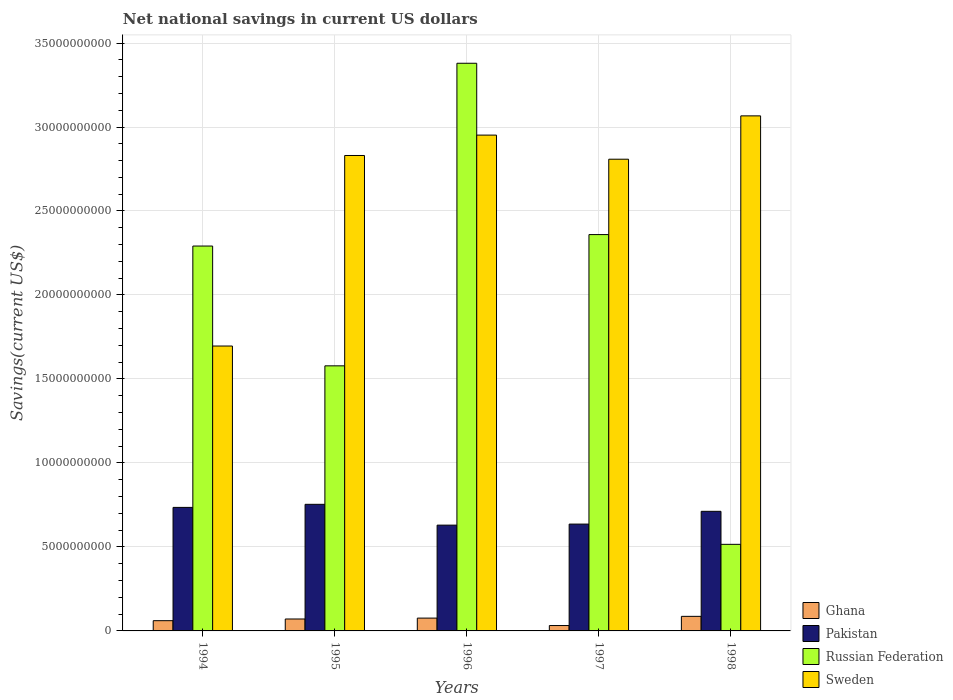How many different coloured bars are there?
Ensure brevity in your answer.  4. How many groups of bars are there?
Your answer should be compact. 5. Are the number of bars on each tick of the X-axis equal?
Keep it short and to the point. Yes. How many bars are there on the 2nd tick from the left?
Make the answer very short. 4. How many bars are there on the 3rd tick from the right?
Keep it short and to the point. 4. What is the net national savings in Russian Federation in 1998?
Ensure brevity in your answer.  5.16e+09. Across all years, what is the maximum net national savings in Sweden?
Give a very brief answer. 3.07e+1. Across all years, what is the minimum net national savings in Sweden?
Your response must be concise. 1.70e+1. In which year was the net national savings in Sweden maximum?
Ensure brevity in your answer.  1998. In which year was the net national savings in Pakistan minimum?
Provide a succinct answer. 1996. What is the total net national savings in Russian Federation in the graph?
Keep it short and to the point. 1.01e+11. What is the difference between the net national savings in Ghana in 1994 and that in 1995?
Your answer should be very brief. -1.01e+08. What is the difference between the net national savings in Russian Federation in 1996 and the net national savings in Sweden in 1994?
Your response must be concise. 1.68e+1. What is the average net national savings in Pakistan per year?
Offer a very short reply. 6.93e+09. In the year 1994, what is the difference between the net national savings in Pakistan and net national savings in Russian Federation?
Make the answer very short. -1.56e+1. What is the ratio of the net national savings in Sweden in 1995 to that in 1997?
Offer a very short reply. 1.01. Is the net national savings in Ghana in 1994 less than that in 1997?
Your answer should be compact. No. What is the difference between the highest and the second highest net national savings in Sweden?
Keep it short and to the point. 1.14e+09. What is the difference between the highest and the lowest net national savings in Ghana?
Offer a terse response. 5.46e+08. Is the sum of the net national savings in Ghana in 1994 and 1996 greater than the maximum net national savings in Pakistan across all years?
Provide a succinct answer. No. What does the 4th bar from the left in 1996 represents?
Your answer should be very brief. Sweden. What does the 3rd bar from the right in 1994 represents?
Your response must be concise. Pakistan. Is it the case that in every year, the sum of the net national savings in Ghana and net national savings in Sweden is greater than the net national savings in Russian Federation?
Offer a terse response. No. Are all the bars in the graph horizontal?
Your answer should be compact. No. Are the values on the major ticks of Y-axis written in scientific E-notation?
Give a very brief answer. No. Does the graph contain any zero values?
Give a very brief answer. No. Does the graph contain grids?
Your response must be concise. Yes. How are the legend labels stacked?
Provide a succinct answer. Vertical. What is the title of the graph?
Offer a terse response. Net national savings in current US dollars. What is the label or title of the Y-axis?
Make the answer very short. Savings(current US$). What is the Savings(current US$) in Ghana in 1994?
Keep it short and to the point. 6.09e+08. What is the Savings(current US$) of Pakistan in 1994?
Provide a succinct answer. 7.35e+09. What is the Savings(current US$) in Russian Federation in 1994?
Provide a short and direct response. 2.29e+1. What is the Savings(current US$) in Sweden in 1994?
Provide a succinct answer. 1.70e+1. What is the Savings(current US$) of Ghana in 1995?
Your response must be concise. 7.11e+08. What is the Savings(current US$) of Pakistan in 1995?
Provide a succinct answer. 7.54e+09. What is the Savings(current US$) in Russian Federation in 1995?
Your answer should be compact. 1.58e+1. What is the Savings(current US$) of Sweden in 1995?
Make the answer very short. 2.83e+1. What is the Savings(current US$) in Ghana in 1996?
Give a very brief answer. 7.63e+08. What is the Savings(current US$) of Pakistan in 1996?
Offer a terse response. 6.30e+09. What is the Savings(current US$) of Russian Federation in 1996?
Your answer should be very brief. 3.38e+1. What is the Savings(current US$) in Sweden in 1996?
Ensure brevity in your answer.  2.95e+1. What is the Savings(current US$) of Ghana in 1997?
Ensure brevity in your answer.  3.21e+08. What is the Savings(current US$) of Pakistan in 1997?
Keep it short and to the point. 6.36e+09. What is the Savings(current US$) of Russian Federation in 1997?
Offer a very short reply. 2.36e+1. What is the Savings(current US$) in Sweden in 1997?
Your response must be concise. 2.81e+1. What is the Savings(current US$) of Ghana in 1998?
Provide a short and direct response. 8.67e+08. What is the Savings(current US$) in Pakistan in 1998?
Give a very brief answer. 7.12e+09. What is the Savings(current US$) of Russian Federation in 1998?
Offer a very short reply. 5.16e+09. What is the Savings(current US$) of Sweden in 1998?
Provide a short and direct response. 3.07e+1. Across all years, what is the maximum Savings(current US$) of Ghana?
Provide a short and direct response. 8.67e+08. Across all years, what is the maximum Savings(current US$) of Pakistan?
Ensure brevity in your answer.  7.54e+09. Across all years, what is the maximum Savings(current US$) in Russian Federation?
Keep it short and to the point. 3.38e+1. Across all years, what is the maximum Savings(current US$) in Sweden?
Provide a short and direct response. 3.07e+1. Across all years, what is the minimum Savings(current US$) in Ghana?
Give a very brief answer. 3.21e+08. Across all years, what is the minimum Savings(current US$) of Pakistan?
Your answer should be very brief. 6.30e+09. Across all years, what is the minimum Savings(current US$) of Russian Federation?
Your answer should be very brief. 5.16e+09. Across all years, what is the minimum Savings(current US$) of Sweden?
Ensure brevity in your answer.  1.70e+1. What is the total Savings(current US$) of Ghana in the graph?
Provide a short and direct response. 3.27e+09. What is the total Savings(current US$) in Pakistan in the graph?
Your response must be concise. 3.47e+1. What is the total Savings(current US$) of Russian Federation in the graph?
Give a very brief answer. 1.01e+11. What is the total Savings(current US$) in Sweden in the graph?
Make the answer very short. 1.34e+11. What is the difference between the Savings(current US$) of Ghana in 1994 and that in 1995?
Your answer should be compact. -1.01e+08. What is the difference between the Savings(current US$) of Pakistan in 1994 and that in 1995?
Give a very brief answer. -1.84e+08. What is the difference between the Savings(current US$) in Russian Federation in 1994 and that in 1995?
Provide a short and direct response. 7.13e+09. What is the difference between the Savings(current US$) in Sweden in 1994 and that in 1995?
Your response must be concise. -1.13e+1. What is the difference between the Savings(current US$) in Ghana in 1994 and that in 1996?
Provide a short and direct response. -1.54e+08. What is the difference between the Savings(current US$) of Pakistan in 1994 and that in 1996?
Offer a terse response. 1.06e+09. What is the difference between the Savings(current US$) of Russian Federation in 1994 and that in 1996?
Your answer should be very brief. -1.09e+1. What is the difference between the Savings(current US$) of Sweden in 1994 and that in 1996?
Ensure brevity in your answer.  -1.26e+1. What is the difference between the Savings(current US$) of Ghana in 1994 and that in 1997?
Provide a short and direct response. 2.88e+08. What is the difference between the Savings(current US$) in Pakistan in 1994 and that in 1997?
Ensure brevity in your answer.  9.93e+08. What is the difference between the Savings(current US$) of Russian Federation in 1994 and that in 1997?
Provide a succinct answer. -6.82e+08. What is the difference between the Savings(current US$) in Sweden in 1994 and that in 1997?
Give a very brief answer. -1.11e+1. What is the difference between the Savings(current US$) in Ghana in 1994 and that in 1998?
Give a very brief answer. -2.58e+08. What is the difference between the Savings(current US$) of Pakistan in 1994 and that in 1998?
Provide a short and direct response. 2.33e+08. What is the difference between the Savings(current US$) in Russian Federation in 1994 and that in 1998?
Keep it short and to the point. 1.78e+1. What is the difference between the Savings(current US$) in Sweden in 1994 and that in 1998?
Ensure brevity in your answer.  -1.37e+1. What is the difference between the Savings(current US$) in Ghana in 1995 and that in 1996?
Provide a short and direct response. -5.24e+07. What is the difference between the Savings(current US$) of Pakistan in 1995 and that in 1996?
Your response must be concise. 1.24e+09. What is the difference between the Savings(current US$) of Russian Federation in 1995 and that in 1996?
Make the answer very short. -1.80e+1. What is the difference between the Savings(current US$) in Sweden in 1995 and that in 1996?
Provide a short and direct response. -1.21e+09. What is the difference between the Savings(current US$) in Ghana in 1995 and that in 1997?
Your answer should be compact. 3.90e+08. What is the difference between the Savings(current US$) in Pakistan in 1995 and that in 1997?
Your answer should be very brief. 1.18e+09. What is the difference between the Savings(current US$) of Russian Federation in 1995 and that in 1997?
Your answer should be compact. -7.81e+09. What is the difference between the Savings(current US$) of Sweden in 1995 and that in 1997?
Provide a succinct answer. 2.21e+08. What is the difference between the Savings(current US$) of Ghana in 1995 and that in 1998?
Your answer should be compact. -1.56e+08. What is the difference between the Savings(current US$) in Pakistan in 1995 and that in 1998?
Your response must be concise. 4.17e+08. What is the difference between the Savings(current US$) in Russian Federation in 1995 and that in 1998?
Make the answer very short. 1.06e+1. What is the difference between the Savings(current US$) in Sweden in 1995 and that in 1998?
Your response must be concise. -2.36e+09. What is the difference between the Savings(current US$) of Ghana in 1996 and that in 1997?
Your answer should be very brief. 4.42e+08. What is the difference between the Savings(current US$) of Pakistan in 1996 and that in 1997?
Provide a succinct answer. -6.20e+07. What is the difference between the Savings(current US$) of Russian Federation in 1996 and that in 1997?
Your answer should be compact. 1.02e+1. What is the difference between the Savings(current US$) in Sweden in 1996 and that in 1997?
Your answer should be compact. 1.44e+09. What is the difference between the Savings(current US$) in Ghana in 1996 and that in 1998?
Your response must be concise. -1.04e+08. What is the difference between the Savings(current US$) of Pakistan in 1996 and that in 1998?
Offer a terse response. -8.22e+08. What is the difference between the Savings(current US$) of Russian Federation in 1996 and that in 1998?
Ensure brevity in your answer.  2.86e+1. What is the difference between the Savings(current US$) of Sweden in 1996 and that in 1998?
Give a very brief answer. -1.14e+09. What is the difference between the Savings(current US$) in Ghana in 1997 and that in 1998?
Provide a short and direct response. -5.46e+08. What is the difference between the Savings(current US$) of Pakistan in 1997 and that in 1998?
Offer a very short reply. -7.60e+08. What is the difference between the Savings(current US$) in Russian Federation in 1997 and that in 1998?
Provide a short and direct response. 1.84e+1. What is the difference between the Savings(current US$) of Sweden in 1997 and that in 1998?
Ensure brevity in your answer.  -2.58e+09. What is the difference between the Savings(current US$) in Ghana in 1994 and the Savings(current US$) in Pakistan in 1995?
Offer a very short reply. -6.93e+09. What is the difference between the Savings(current US$) of Ghana in 1994 and the Savings(current US$) of Russian Federation in 1995?
Your response must be concise. -1.52e+1. What is the difference between the Savings(current US$) in Ghana in 1994 and the Savings(current US$) in Sweden in 1995?
Make the answer very short. -2.77e+1. What is the difference between the Savings(current US$) of Pakistan in 1994 and the Savings(current US$) of Russian Federation in 1995?
Provide a succinct answer. -8.43e+09. What is the difference between the Savings(current US$) of Pakistan in 1994 and the Savings(current US$) of Sweden in 1995?
Provide a short and direct response. -2.10e+1. What is the difference between the Savings(current US$) in Russian Federation in 1994 and the Savings(current US$) in Sweden in 1995?
Your answer should be very brief. -5.39e+09. What is the difference between the Savings(current US$) in Ghana in 1994 and the Savings(current US$) in Pakistan in 1996?
Your response must be concise. -5.69e+09. What is the difference between the Savings(current US$) in Ghana in 1994 and the Savings(current US$) in Russian Federation in 1996?
Ensure brevity in your answer.  -3.32e+1. What is the difference between the Savings(current US$) in Ghana in 1994 and the Savings(current US$) in Sweden in 1996?
Your answer should be compact. -2.89e+1. What is the difference between the Savings(current US$) of Pakistan in 1994 and the Savings(current US$) of Russian Federation in 1996?
Ensure brevity in your answer.  -2.64e+1. What is the difference between the Savings(current US$) of Pakistan in 1994 and the Savings(current US$) of Sweden in 1996?
Give a very brief answer. -2.22e+1. What is the difference between the Savings(current US$) in Russian Federation in 1994 and the Savings(current US$) in Sweden in 1996?
Your response must be concise. -6.61e+09. What is the difference between the Savings(current US$) of Ghana in 1994 and the Savings(current US$) of Pakistan in 1997?
Provide a succinct answer. -5.75e+09. What is the difference between the Savings(current US$) of Ghana in 1994 and the Savings(current US$) of Russian Federation in 1997?
Provide a succinct answer. -2.30e+1. What is the difference between the Savings(current US$) in Ghana in 1994 and the Savings(current US$) in Sweden in 1997?
Ensure brevity in your answer.  -2.75e+1. What is the difference between the Savings(current US$) in Pakistan in 1994 and the Savings(current US$) in Russian Federation in 1997?
Give a very brief answer. -1.62e+1. What is the difference between the Savings(current US$) in Pakistan in 1994 and the Savings(current US$) in Sweden in 1997?
Ensure brevity in your answer.  -2.07e+1. What is the difference between the Savings(current US$) of Russian Federation in 1994 and the Savings(current US$) of Sweden in 1997?
Offer a very short reply. -5.17e+09. What is the difference between the Savings(current US$) in Ghana in 1994 and the Savings(current US$) in Pakistan in 1998?
Ensure brevity in your answer.  -6.51e+09. What is the difference between the Savings(current US$) in Ghana in 1994 and the Savings(current US$) in Russian Federation in 1998?
Offer a very short reply. -4.55e+09. What is the difference between the Savings(current US$) of Ghana in 1994 and the Savings(current US$) of Sweden in 1998?
Your answer should be very brief. -3.01e+1. What is the difference between the Savings(current US$) in Pakistan in 1994 and the Savings(current US$) in Russian Federation in 1998?
Your response must be concise. 2.20e+09. What is the difference between the Savings(current US$) of Pakistan in 1994 and the Savings(current US$) of Sweden in 1998?
Your response must be concise. -2.33e+1. What is the difference between the Savings(current US$) in Russian Federation in 1994 and the Savings(current US$) in Sweden in 1998?
Make the answer very short. -7.75e+09. What is the difference between the Savings(current US$) in Ghana in 1995 and the Savings(current US$) in Pakistan in 1996?
Provide a succinct answer. -5.59e+09. What is the difference between the Savings(current US$) in Ghana in 1995 and the Savings(current US$) in Russian Federation in 1996?
Offer a terse response. -3.31e+1. What is the difference between the Savings(current US$) of Ghana in 1995 and the Savings(current US$) of Sweden in 1996?
Offer a very short reply. -2.88e+1. What is the difference between the Savings(current US$) of Pakistan in 1995 and the Savings(current US$) of Russian Federation in 1996?
Your answer should be compact. -2.63e+1. What is the difference between the Savings(current US$) in Pakistan in 1995 and the Savings(current US$) in Sweden in 1996?
Your answer should be compact. -2.20e+1. What is the difference between the Savings(current US$) of Russian Federation in 1995 and the Savings(current US$) of Sweden in 1996?
Give a very brief answer. -1.37e+1. What is the difference between the Savings(current US$) of Ghana in 1995 and the Savings(current US$) of Pakistan in 1997?
Ensure brevity in your answer.  -5.65e+09. What is the difference between the Savings(current US$) of Ghana in 1995 and the Savings(current US$) of Russian Federation in 1997?
Ensure brevity in your answer.  -2.29e+1. What is the difference between the Savings(current US$) in Ghana in 1995 and the Savings(current US$) in Sweden in 1997?
Make the answer very short. -2.74e+1. What is the difference between the Savings(current US$) in Pakistan in 1995 and the Savings(current US$) in Russian Federation in 1997?
Give a very brief answer. -1.61e+1. What is the difference between the Savings(current US$) in Pakistan in 1995 and the Savings(current US$) in Sweden in 1997?
Keep it short and to the point. -2.05e+1. What is the difference between the Savings(current US$) of Russian Federation in 1995 and the Savings(current US$) of Sweden in 1997?
Provide a short and direct response. -1.23e+1. What is the difference between the Savings(current US$) in Ghana in 1995 and the Savings(current US$) in Pakistan in 1998?
Your response must be concise. -6.41e+09. What is the difference between the Savings(current US$) of Ghana in 1995 and the Savings(current US$) of Russian Federation in 1998?
Your answer should be compact. -4.44e+09. What is the difference between the Savings(current US$) of Ghana in 1995 and the Savings(current US$) of Sweden in 1998?
Provide a succinct answer. -3.00e+1. What is the difference between the Savings(current US$) of Pakistan in 1995 and the Savings(current US$) of Russian Federation in 1998?
Make the answer very short. 2.38e+09. What is the difference between the Savings(current US$) in Pakistan in 1995 and the Savings(current US$) in Sweden in 1998?
Offer a very short reply. -2.31e+1. What is the difference between the Savings(current US$) of Russian Federation in 1995 and the Savings(current US$) of Sweden in 1998?
Make the answer very short. -1.49e+1. What is the difference between the Savings(current US$) of Ghana in 1996 and the Savings(current US$) of Pakistan in 1997?
Offer a terse response. -5.60e+09. What is the difference between the Savings(current US$) in Ghana in 1996 and the Savings(current US$) in Russian Federation in 1997?
Your answer should be very brief. -2.28e+1. What is the difference between the Savings(current US$) of Ghana in 1996 and the Savings(current US$) of Sweden in 1997?
Offer a terse response. -2.73e+1. What is the difference between the Savings(current US$) of Pakistan in 1996 and the Savings(current US$) of Russian Federation in 1997?
Provide a succinct answer. -1.73e+1. What is the difference between the Savings(current US$) of Pakistan in 1996 and the Savings(current US$) of Sweden in 1997?
Keep it short and to the point. -2.18e+1. What is the difference between the Savings(current US$) in Russian Federation in 1996 and the Savings(current US$) in Sweden in 1997?
Provide a short and direct response. 5.71e+09. What is the difference between the Savings(current US$) of Ghana in 1996 and the Savings(current US$) of Pakistan in 1998?
Make the answer very short. -6.36e+09. What is the difference between the Savings(current US$) in Ghana in 1996 and the Savings(current US$) in Russian Federation in 1998?
Your answer should be very brief. -4.39e+09. What is the difference between the Savings(current US$) in Ghana in 1996 and the Savings(current US$) in Sweden in 1998?
Give a very brief answer. -2.99e+1. What is the difference between the Savings(current US$) in Pakistan in 1996 and the Savings(current US$) in Russian Federation in 1998?
Provide a short and direct response. 1.14e+09. What is the difference between the Savings(current US$) of Pakistan in 1996 and the Savings(current US$) of Sweden in 1998?
Your answer should be very brief. -2.44e+1. What is the difference between the Savings(current US$) in Russian Federation in 1996 and the Savings(current US$) in Sweden in 1998?
Keep it short and to the point. 3.13e+09. What is the difference between the Savings(current US$) of Ghana in 1997 and the Savings(current US$) of Pakistan in 1998?
Provide a short and direct response. -6.80e+09. What is the difference between the Savings(current US$) in Ghana in 1997 and the Savings(current US$) in Russian Federation in 1998?
Offer a very short reply. -4.83e+09. What is the difference between the Savings(current US$) in Ghana in 1997 and the Savings(current US$) in Sweden in 1998?
Provide a succinct answer. -3.03e+1. What is the difference between the Savings(current US$) in Pakistan in 1997 and the Savings(current US$) in Russian Federation in 1998?
Ensure brevity in your answer.  1.20e+09. What is the difference between the Savings(current US$) in Pakistan in 1997 and the Savings(current US$) in Sweden in 1998?
Give a very brief answer. -2.43e+1. What is the difference between the Savings(current US$) of Russian Federation in 1997 and the Savings(current US$) of Sweden in 1998?
Make the answer very short. -7.07e+09. What is the average Savings(current US$) of Ghana per year?
Your response must be concise. 6.54e+08. What is the average Savings(current US$) of Pakistan per year?
Keep it short and to the point. 6.93e+09. What is the average Savings(current US$) in Russian Federation per year?
Provide a succinct answer. 2.02e+1. What is the average Savings(current US$) of Sweden per year?
Keep it short and to the point. 2.67e+1. In the year 1994, what is the difference between the Savings(current US$) of Ghana and Savings(current US$) of Pakistan?
Offer a terse response. -6.74e+09. In the year 1994, what is the difference between the Savings(current US$) in Ghana and Savings(current US$) in Russian Federation?
Provide a succinct answer. -2.23e+1. In the year 1994, what is the difference between the Savings(current US$) of Ghana and Savings(current US$) of Sweden?
Provide a short and direct response. -1.64e+1. In the year 1994, what is the difference between the Savings(current US$) in Pakistan and Savings(current US$) in Russian Federation?
Provide a succinct answer. -1.56e+1. In the year 1994, what is the difference between the Savings(current US$) in Pakistan and Savings(current US$) in Sweden?
Make the answer very short. -9.61e+09. In the year 1994, what is the difference between the Savings(current US$) in Russian Federation and Savings(current US$) in Sweden?
Provide a short and direct response. 5.95e+09. In the year 1995, what is the difference between the Savings(current US$) of Ghana and Savings(current US$) of Pakistan?
Your answer should be very brief. -6.83e+09. In the year 1995, what is the difference between the Savings(current US$) in Ghana and Savings(current US$) in Russian Federation?
Provide a succinct answer. -1.51e+1. In the year 1995, what is the difference between the Savings(current US$) of Ghana and Savings(current US$) of Sweden?
Offer a very short reply. -2.76e+1. In the year 1995, what is the difference between the Savings(current US$) in Pakistan and Savings(current US$) in Russian Federation?
Ensure brevity in your answer.  -8.24e+09. In the year 1995, what is the difference between the Savings(current US$) of Pakistan and Savings(current US$) of Sweden?
Your response must be concise. -2.08e+1. In the year 1995, what is the difference between the Savings(current US$) in Russian Federation and Savings(current US$) in Sweden?
Ensure brevity in your answer.  -1.25e+1. In the year 1996, what is the difference between the Savings(current US$) in Ghana and Savings(current US$) in Pakistan?
Your answer should be very brief. -5.54e+09. In the year 1996, what is the difference between the Savings(current US$) in Ghana and Savings(current US$) in Russian Federation?
Offer a very short reply. -3.30e+1. In the year 1996, what is the difference between the Savings(current US$) in Ghana and Savings(current US$) in Sweden?
Your answer should be very brief. -2.88e+1. In the year 1996, what is the difference between the Savings(current US$) of Pakistan and Savings(current US$) of Russian Federation?
Keep it short and to the point. -2.75e+1. In the year 1996, what is the difference between the Savings(current US$) of Pakistan and Savings(current US$) of Sweden?
Ensure brevity in your answer.  -2.32e+1. In the year 1996, what is the difference between the Savings(current US$) in Russian Federation and Savings(current US$) in Sweden?
Your answer should be compact. 4.28e+09. In the year 1997, what is the difference between the Savings(current US$) of Ghana and Savings(current US$) of Pakistan?
Offer a terse response. -6.04e+09. In the year 1997, what is the difference between the Savings(current US$) of Ghana and Savings(current US$) of Russian Federation?
Offer a terse response. -2.33e+1. In the year 1997, what is the difference between the Savings(current US$) in Ghana and Savings(current US$) in Sweden?
Your answer should be very brief. -2.78e+1. In the year 1997, what is the difference between the Savings(current US$) in Pakistan and Savings(current US$) in Russian Federation?
Provide a short and direct response. -1.72e+1. In the year 1997, what is the difference between the Savings(current US$) in Pakistan and Savings(current US$) in Sweden?
Keep it short and to the point. -2.17e+1. In the year 1997, what is the difference between the Savings(current US$) in Russian Federation and Savings(current US$) in Sweden?
Keep it short and to the point. -4.49e+09. In the year 1998, what is the difference between the Savings(current US$) of Ghana and Savings(current US$) of Pakistan?
Your answer should be very brief. -6.25e+09. In the year 1998, what is the difference between the Savings(current US$) of Ghana and Savings(current US$) of Russian Federation?
Make the answer very short. -4.29e+09. In the year 1998, what is the difference between the Savings(current US$) in Ghana and Savings(current US$) in Sweden?
Your response must be concise. -2.98e+1. In the year 1998, what is the difference between the Savings(current US$) of Pakistan and Savings(current US$) of Russian Federation?
Your answer should be very brief. 1.97e+09. In the year 1998, what is the difference between the Savings(current US$) in Pakistan and Savings(current US$) in Sweden?
Ensure brevity in your answer.  -2.35e+1. In the year 1998, what is the difference between the Savings(current US$) of Russian Federation and Savings(current US$) of Sweden?
Your answer should be compact. -2.55e+1. What is the ratio of the Savings(current US$) in Ghana in 1994 to that in 1995?
Your answer should be compact. 0.86. What is the ratio of the Savings(current US$) in Pakistan in 1994 to that in 1995?
Your answer should be very brief. 0.98. What is the ratio of the Savings(current US$) in Russian Federation in 1994 to that in 1995?
Your response must be concise. 1.45. What is the ratio of the Savings(current US$) of Sweden in 1994 to that in 1995?
Your response must be concise. 0.6. What is the ratio of the Savings(current US$) in Ghana in 1994 to that in 1996?
Keep it short and to the point. 0.8. What is the ratio of the Savings(current US$) of Pakistan in 1994 to that in 1996?
Provide a succinct answer. 1.17. What is the ratio of the Savings(current US$) of Russian Federation in 1994 to that in 1996?
Make the answer very short. 0.68. What is the ratio of the Savings(current US$) in Sweden in 1994 to that in 1996?
Your response must be concise. 0.57. What is the ratio of the Savings(current US$) of Ghana in 1994 to that in 1997?
Provide a short and direct response. 1.9. What is the ratio of the Savings(current US$) in Pakistan in 1994 to that in 1997?
Provide a short and direct response. 1.16. What is the ratio of the Savings(current US$) of Russian Federation in 1994 to that in 1997?
Make the answer very short. 0.97. What is the ratio of the Savings(current US$) in Sweden in 1994 to that in 1997?
Provide a succinct answer. 0.6. What is the ratio of the Savings(current US$) in Ghana in 1994 to that in 1998?
Provide a succinct answer. 0.7. What is the ratio of the Savings(current US$) in Pakistan in 1994 to that in 1998?
Your answer should be very brief. 1.03. What is the ratio of the Savings(current US$) of Russian Federation in 1994 to that in 1998?
Provide a succinct answer. 4.44. What is the ratio of the Savings(current US$) in Sweden in 1994 to that in 1998?
Provide a succinct answer. 0.55. What is the ratio of the Savings(current US$) in Ghana in 1995 to that in 1996?
Keep it short and to the point. 0.93. What is the ratio of the Savings(current US$) in Pakistan in 1995 to that in 1996?
Your answer should be compact. 1.2. What is the ratio of the Savings(current US$) in Russian Federation in 1995 to that in 1996?
Provide a succinct answer. 0.47. What is the ratio of the Savings(current US$) in Sweden in 1995 to that in 1996?
Offer a very short reply. 0.96. What is the ratio of the Savings(current US$) of Ghana in 1995 to that in 1997?
Ensure brevity in your answer.  2.21. What is the ratio of the Savings(current US$) in Pakistan in 1995 to that in 1997?
Provide a short and direct response. 1.19. What is the ratio of the Savings(current US$) of Russian Federation in 1995 to that in 1997?
Offer a very short reply. 0.67. What is the ratio of the Savings(current US$) of Sweden in 1995 to that in 1997?
Provide a succinct answer. 1.01. What is the ratio of the Savings(current US$) in Ghana in 1995 to that in 1998?
Provide a short and direct response. 0.82. What is the ratio of the Savings(current US$) in Pakistan in 1995 to that in 1998?
Your response must be concise. 1.06. What is the ratio of the Savings(current US$) in Russian Federation in 1995 to that in 1998?
Your response must be concise. 3.06. What is the ratio of the Savings(current US$) in Sweden in 1995 to that in 1998?
Offer a terse response. 0.92. What is the ratio of the Savings(current US$) of Ghana in 1996 to that in 1997?
Keep it short and to the point. 2.38. What is the ratio of the Savings(current US$) in Pakistan in 1996 to that in 1997?
Keep it short and to the point. 0.99. What is the ratio of the Savings(current US$) in Russian Federation in 1996 to that in 1997?
Give a very brief answer. 1.43. What is the ratio of the Savings(current US$) in Sweden in 1996 to that in 1997?
Keep it short and to the point. 1.05. What is the ratio of the Savings(current US$) of Ghana in 1996 to that in 1998?
Provide a short and direct response. 0.88. What is the ratio of the Savings(current US$) of Pakistan in 1996 to that in 1998?
Keep it short and to the point. 0.88. What is the ratio of the Savings(current US$) in Russian Federation in 1996 to that in 1998?
Your answer should be very brief. 6.56. What is the ratio of the Savings(current US$) of Sweden in 1996 to that in 1998?
Provide a short and direct response. 0.96. What is the ratio of the Savings(current US$) in Ghana in 1997 to that in 1998?
Your response must be concise. 0.37. What is the ratio of the Savings(current US$) of Pakistan in 1997 to that in 1998?
Provide a succinct answer. 0.89. What is the ratio of the Savings(current US$) in Russian Federation in 1997 to that in 1998?
Ensure brevity in your answer.  4.58. What is the ratio of the Savings(current US$) of Sweden in 1997 to that in 1998?
Your response must be concise. 0.92. What is the difference between the highest and the second highest Savings(current US$) in Ghana?
Your response must be concise. 1.04e+08. What is the difference between the highest and the second highest Savings(current US$) in Pakistan?
Provide a succinct answer. 1.84e+08. What is the difference between the highest and the second highest Savings(current US$) in Russian Federation?
Your answer should be compact. 1.02e+1. What is the difference between the highest and the second highest Savings(current US$) of Sweden?
Make the answer very short. 1.14e+09. What is the difference between the highest and the lowest Savings(current US$) in Ghana?
Provide a succinct answer. 5.46e+08. What is the difference between the highest and the lowest Savings(current US$) of Pakistan?
Offer a terse response. 1.24e+09. What is the difference between the highest and the lowest Savings(current US$) of Russian Federation?
Provide a succinct answer. 2.86e+1. What is the difference between the highest and the lowest Savings(current US$) of Sweden?
Offer a very short reply. 1.37e+1. 